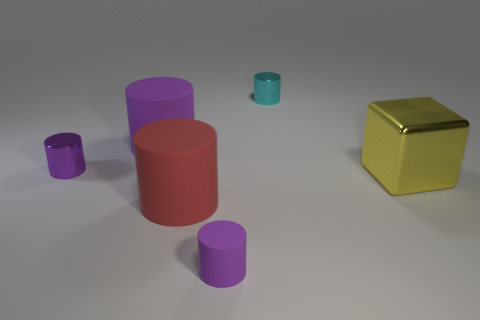There is a cylinder that is behind the tiny purple metal thing and left of the red thing; what material is it made of?
Your answer should be very brief. Rubber. How many purple matte cylinders are on the right side of the purple matte object on the left side of the tiny matte cylinder?
Offer a very short reply. 1. There is a yellow object; what shape is it?
Your answer should be compact. Cube. What is the shape of the small cyan thing that is made of the same material as the yellow cube?
Your answer should be very brief. Cylinder. There is a large matte object that is in front of the yellow metallic cube; is it the same shape as the big purple object?
Keep it short and to the point. Yes. What is the shape of the tiny object that is in front of the purple shiny cylinder?
Provide a succinct answer. Cylinder. What shape is the other matte thing that is the same color as the small rubber thing?
Give a very brief answer. Cylinder. What number of yellow rubber cubes are the same size as the purple shiny cylinder?
Your answer should be very brief. 0. The metal block is what color?
Keep it short and to the point. Yellow. There is a big metal thing; does it have the same color as the small object to the left of the red matte cylinder?
Offer a very short reply. No. 